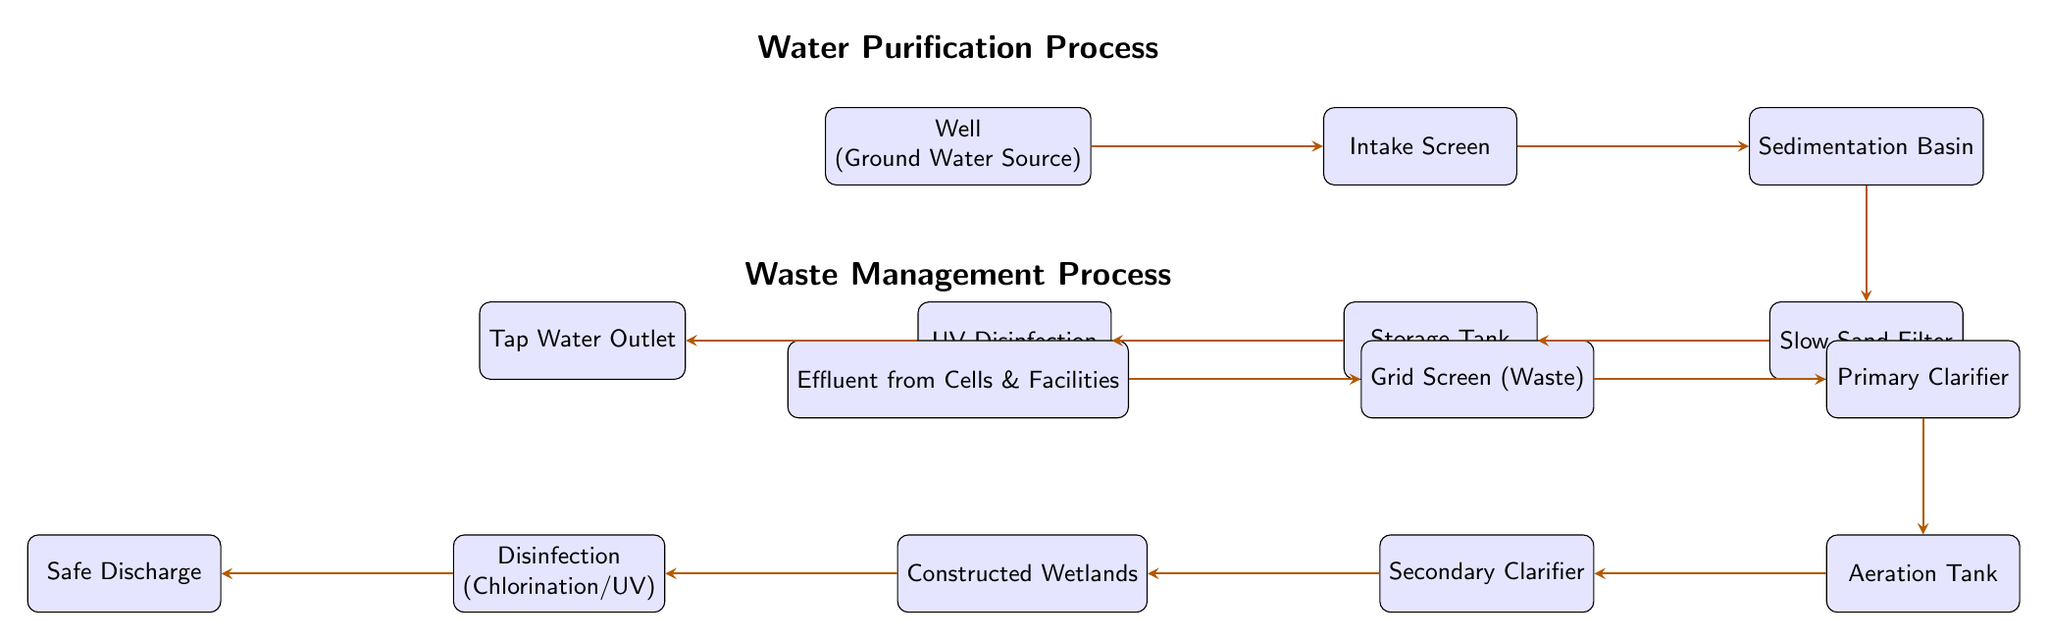What is the water source used in the purification process? The diagram shows "Well (Ground Water Source)" as the starting point of the water purification process, indicating that the source of water for treatment is from a well.
Answer: Well (Ground Water Source) What is the last step in the water treatment process? The diagram clearly indicates that the last step in the water purification process is "Tap Water Outlet," which is where treated water is accessed.
Answer: Tap Water Outlet How many nodes are in the waste management process? By counting the distinct boxes within the waste management section of the diagram, there are a total of six nodes: Effluent, Grid Screen, Primary Clarifier, Aeration Tank, Secondary Clarifier, and Constructed Wetlands, plus Disinfection and Discharge.
Answer: 8 What process follows the aeration tank? The diagram illustrates a flow from "Aeration Tank" to "Secondary Clarifier," indicating that the next step after aeration is clarification.
Answer: Secondary Clarifier What method is used for final disinfection in waste management? The diagram specifies that the method for final disinfection is either "Chlorination" or "UV," highlighting these as options for ensuring the safety of the discharged water.
Answer: Chlorination/UV What is removed at the intake screen? According to the diagram, the intake screen's function is to "Remove Debris," which means it filters out unwanted materials before water moves to the sedimentation basin.
Answer: Remove Debris Which component features natural filtration in the waste management process? The component labeled "Constructed Wetlands" is specifically identified in the diagram as involving "Natural Filtration," showing its contribution to waste management through natural processes.
Answer: Constructed Wetlands What does the sedimentation basin do? The diagram indicates that the sedimentation basin is involved in "Pre-Filtration," which allows larger particles to settle before further purification steps are taken.
Answer: Pre-Filtration 